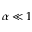Convert formula to latex. <formula><loc_0><loc_0><loc_500><loc_500>{ \alpha } \ll 1</formula> 